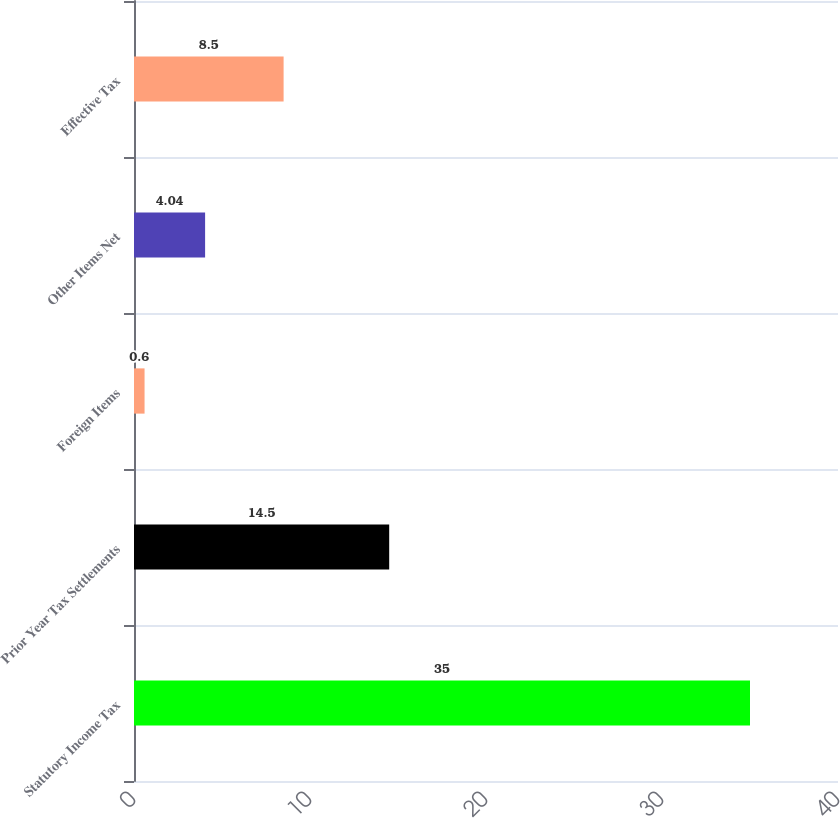Convert chart. <chart><loc_0><loc_0><loc_500><loc_500><bar_chart><fcel>Statutory Income Tax<fcel>Prior Year Tax Settlements<fcel>Foreign Items<fcel>Other Items Net<fcel>Effective Tax<nl><fcel>35<fcel>14.5<fcel>0.6<fcel>4.04<fcel>8.5<nl></chart> 